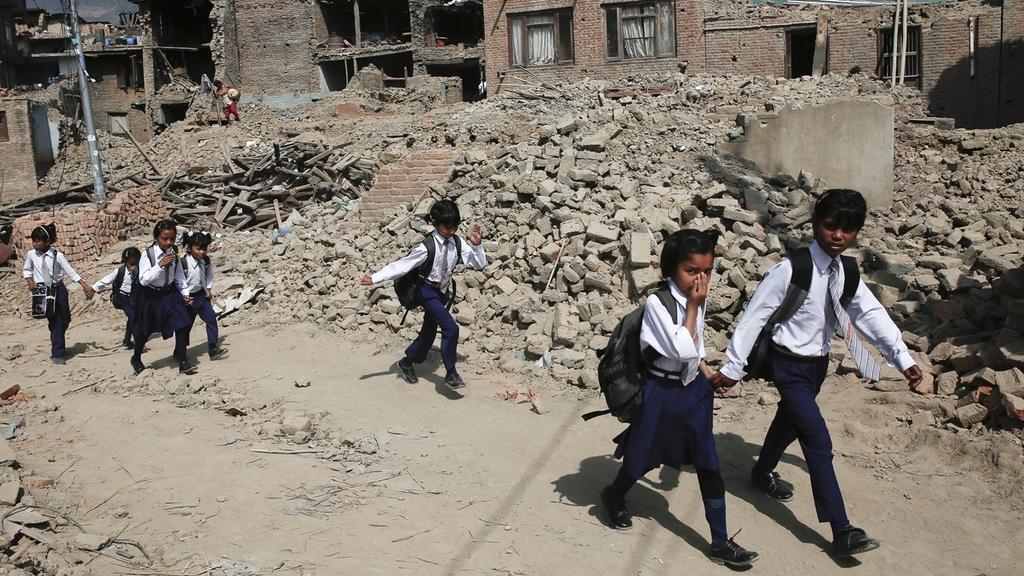In one or two sentences, can you explain what this image depicts? In this image we can see children wearing uniforms and walking. In the background there are buildings, bricks, poles and logs. 